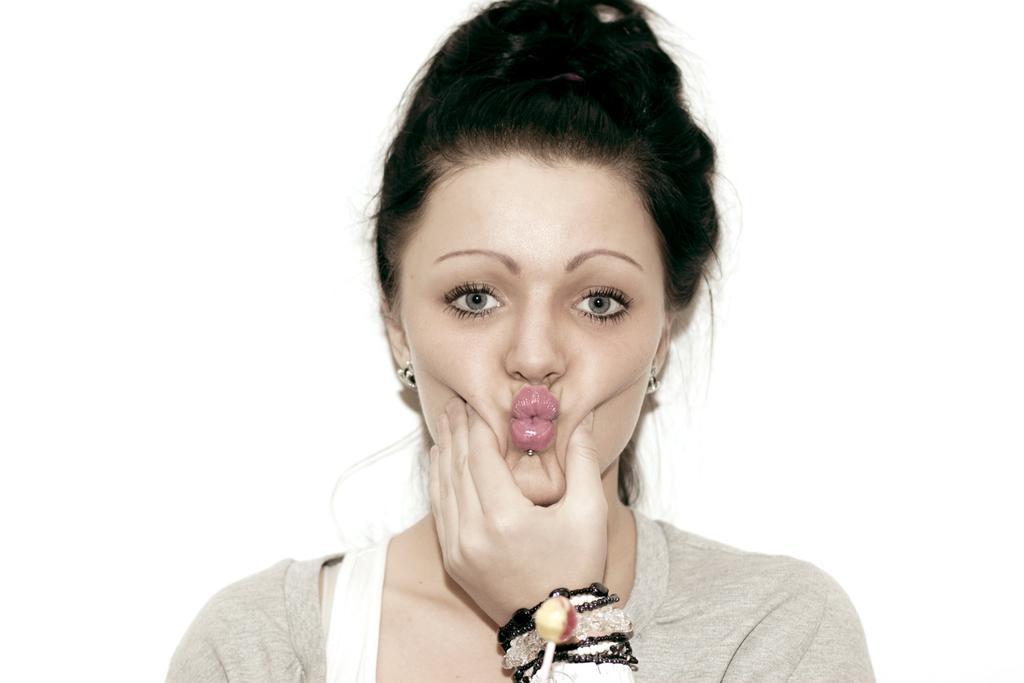Who is the main subject in the image? There is a woman in the image. What is the woman doing in the image? The woman is holding her cheeks in the image. What object can be seen in the image besides the woman? There is a lollipop in the image. What is the color of the background in the image? The background of the image is white. Can you tell me how many wings the woman has in the image? There are no wings present in the image, so it is not possible to determine the number of wings the woman has. 